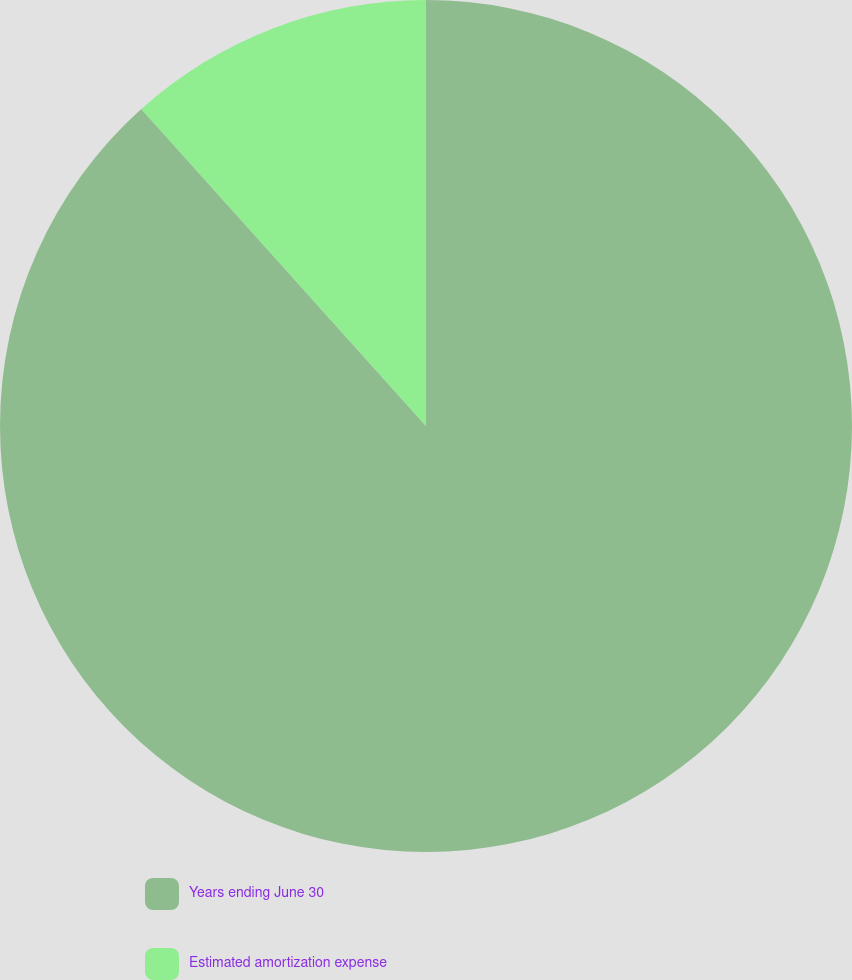Convert chart to OTSL. <chart><loc_0><loc_0><loc_500><loc_500><pie_chart><fcel>Years ending June 30<fcel>Estimated amortization expense<nl><fcel>88.35%<fcel>11.65%<nl></chart> 